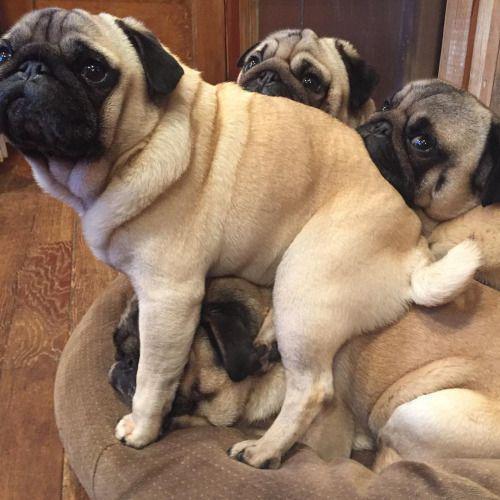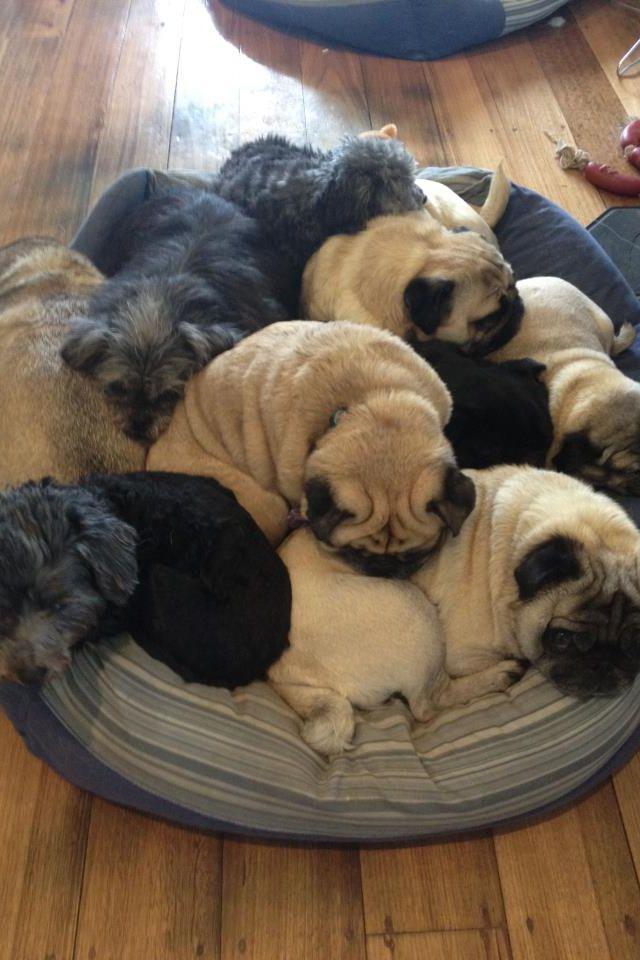The first image is the image on the left, the second image is the image on the right. Examine the images to the left and right. Is the description "There are more dogs in the image on the right." accurate? Answer yes or no. Yes. The first image is the image on the left, the second image is the image on the right. Given the left and right images, does the statement "Each image includes buff-beige pugs with dark muzzles, and no image contains fewer than three pugs." hold true? Answer yes or no. Yes. 